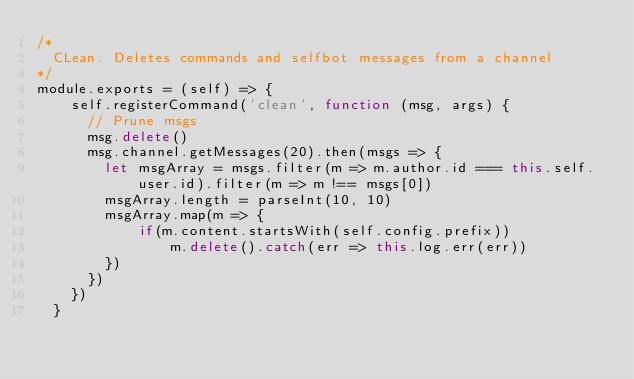<code> <loc_0><loc_0><loc_500><loc_500><_JavaScript_>/*
  CLean. Deletes commands and selfbot messages from a channel
*/
module.exports = (self) => {
    self.registerCommand('clean', function (msg, args) {
      // Prune msgs
      msg.delete()
      msg.channel.getMessages(20).then(msgs => {
        let msgArray = msgs.filter(m => m.author.id === this.self.user.id).filter(m => m !== msgs[0])
        msgArray.length = parseInt(10, 10)
        msgArray.map(m => {
            if(m.content.startsWith(self.config.prefix))
                m.delete().catch(err => this.log.err(err))
        })
      })
    })
  }
  </code> 